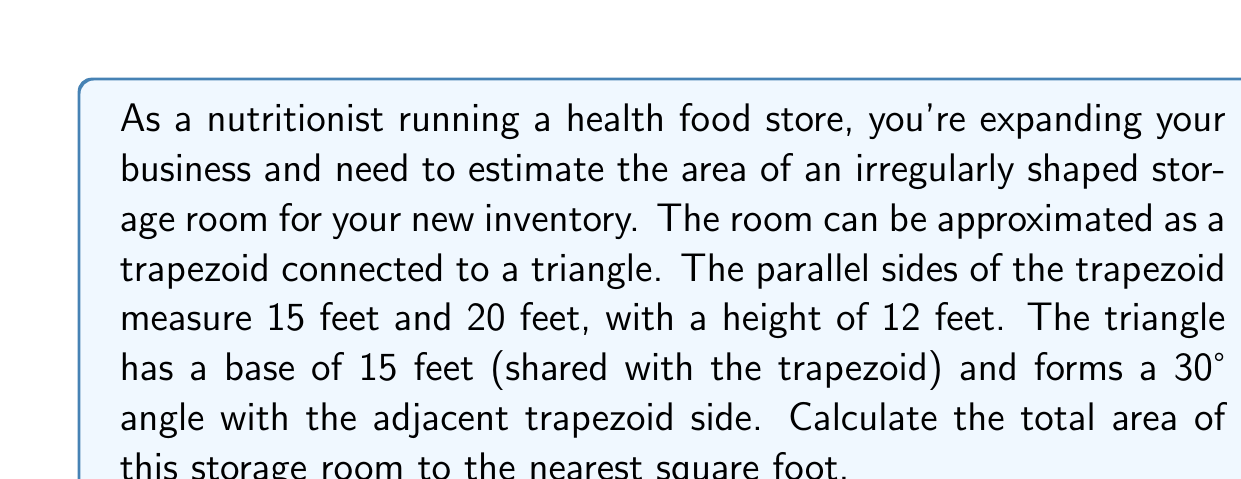Give your solution to this math problem. Let's break this down step-by-step:

1) First, we'll calculate the area of the trapezoid:
   Area of trapezoid = $\frac{1}{2}(a+b)h$
   Where $a$ and $b$ are the parallel sides, and $h$ is the height
   $$A_{trapezoid} = \frac{1}{2}(15+20) \times 12 = \frac{35}{2} \times 12 = 210\text{ sq ft}$$

2) Now, for the triangle, we know the base (15 ft) and one angle (30°). We need to find the height:
   $\tan 30° = \frac{\text{height}}{\text{base}}$
   $\text{height} = 15 \times \tan 30°$
   $$\text{height} = 15 \times \frac{1}{\sqrt{3}} \approx 8.66\text{ ft}$$

3) Now we can calculate the area of the triangle:
   $$A_{triangle} = \frac{1}{2} \times 15 \times 8.66 \approx 64.95\text{ sq ft}$$

4) The total area is the sum of the trapezoid and triangle areas:
   $$A_{total} = 210 + 64.95 = 274.95\text{ sq ft}$$

5) Rounding to the nearest square foot:
   $$A_{total} \approx 275\text{ sq ft}$$

[asy]
import geometry;

pair A=(0,0), B=(20,0), C=(15,12), D=(0,12), E=(30,12);
draw(A--B--C--D--cycle);
draw(C--E);
label("15'", (D--C), N);
label("20'", (A--B), S);
label("12'", (A--D), W);
label("15'", (C--E), NE);
label("30°", C, NW);
[/asy]
Answer: 275 sq ft 